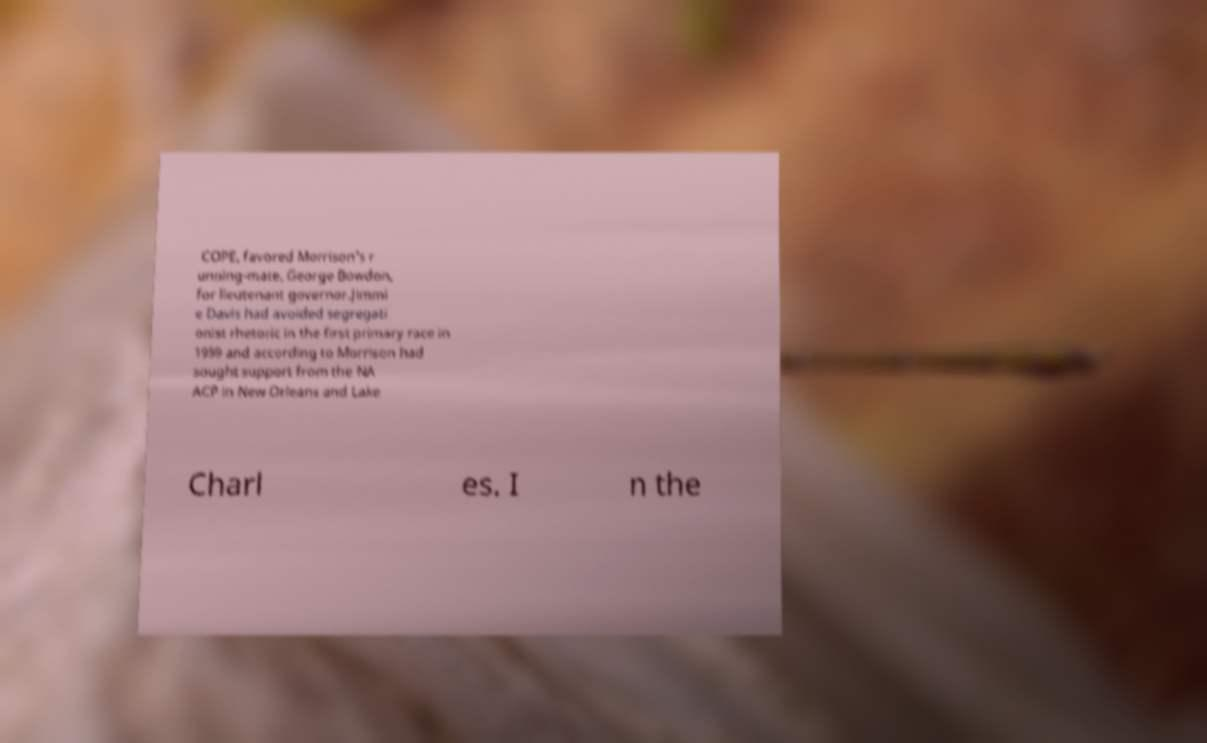Please identify and transcribe the text found in this image. COPE, favored Morrison's r unning-mate, George Bowdon, for lieutenant governor.Jimmi e Davis had avoided segregati onist rhetoric in the first primary race in 1959 and according to Morrison had sought support from the NA ACP in New Orleans and Lake Charl es. I n the 